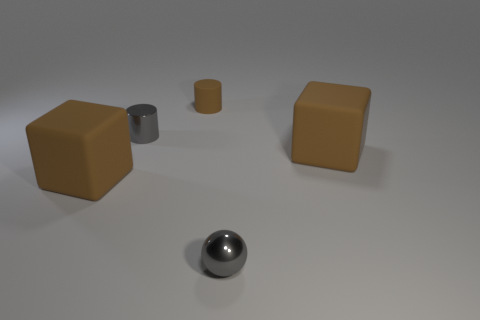Is the number of small shiny things that are in front of the small shiny cylinder greater than the number of large blue shiny blocks?
Provide a succinct answer. Yes. Is the number of brown rubber blocks that are on the left side of the tiny matte object the same as the number of big things on the right side of the gray shiny sphere?
Provide a short and direct response. Yes. Are there any small brown rubber cylinders behind the large rubber cube that is left of the brown cylinder?
Make the answer very short. Yes. There is a metal cylinder that is the same color as the tiny sphere; what is its size?
Make the answer very short. Small. What size is the matte cylinder that is behind the small gray object left of the gray metal ball?
Provide a succinct answer. Small. What is the size of the metallic object that is behind the metallic ball?
Ensure brevity in your answer.  Small. Are there fewer objects in front of the tiny gray metallic cylinder than big rubber cubes left of the sphere?
Provide a succinct answer. No. What color is the shiny ball?
Keep it short and to the point. Gray. Are there any big rubber cubes that have the same color as the matte cylinder?
Keep it short and to the point. Yes. What shape is the brown rubber object that is to the right of the gray thing that is in front of the small gray object behind the gray ball?
Your response must be concise. Cube. 